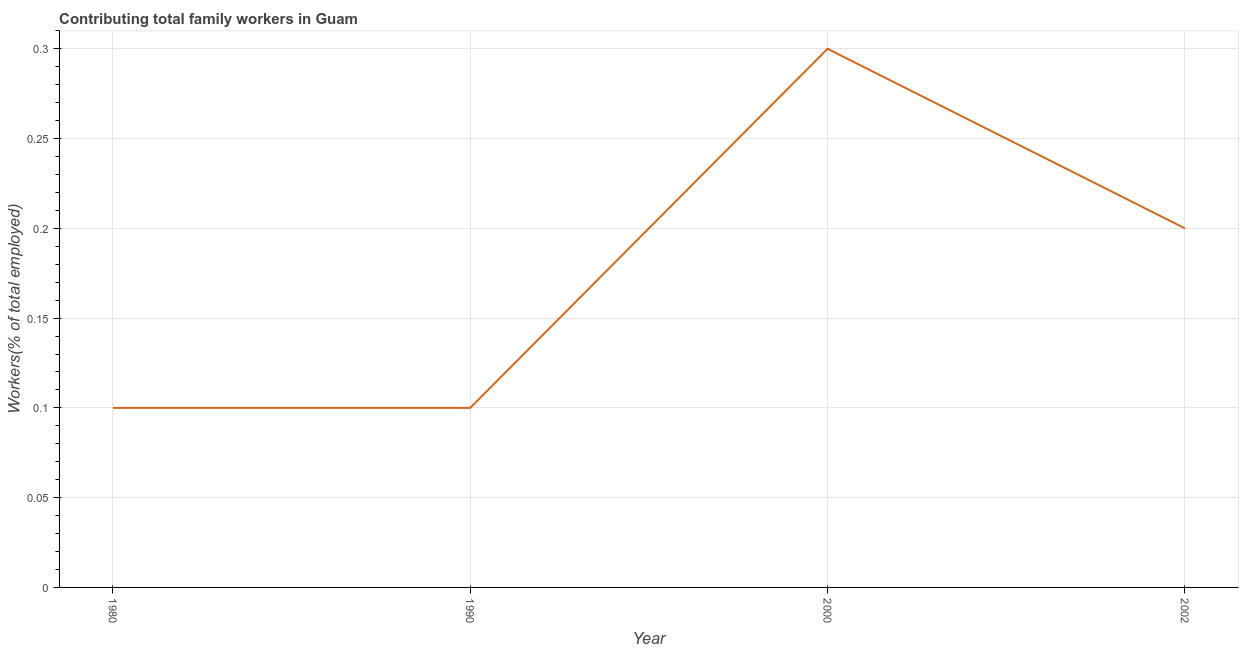What is the contributing family workers in 2000?
Your answer should be compact. 0.3. Across all years, what is the maximum contributing family workers?
Provide a succinct answer. 0.3. Across all years, what is the minimum contributing family workers?
Keep it short and to the point. 0.1. What is the sum of the contributing family workers?
Ensure brevity in your answer.  0.7. What is the difference between the contributing family workers in 1980 and 1990?
Ensure brevity in your answer.  0. What is the average contributing family workers per year?
Make the answer very short. 0.18. What is the median contributing family workers?
Give a very brief answer. 0.15. What is the ratio of the contributing family workers in 1990 to that in 2000?
Give a very brief answer. 0.33. Is the contributing family workers in 2000 less than that in 2002?
Your response must be concise. No. Is the difference between the contributing family workers in 1990 and 2002 greater than the difference between any two years?
Offer a terse response. No. What is the difference between the highest and the second highest contributing family workers?
Keep it short and to the point. 0.1. Is the sum of the contributing family workers in 1980 and 2000 greater than the maximum contributing family workers across all years?
Offer a terse response. Yes. What is the difference between the highest and the lowest contributing family workers?
Keep it short and to the point. 0.2. How many lines are there?
Ensure brevity in your answer.  1. What is the difference between two consecutive major ticks on the Y-axis?
Your response must be concise. 0.05. Are the values on the major ticks of Y-axis written in scientific E-notation?
Offer a terse response. No. Does the graph contain any zero values?
Offer a very short reply. No. What is the title of the graph?
Ensure brevity in your answer.  Contributing total family workers in Guam. What is the label or title of the Y-axis?
Offer a very short reply. Workers(% of total employed). What is the Workers(% of total employed) of 1980?
Give a very brief answer. 0.1. What is the Workers(% of total employed) in 1990?
Ensure brevity in your answer.  0.1. What is the Workers(% of total employed) in 2000?
Make the answer very short. 0.3. What is the Workers(% of total employed) in 2002?
Provide a succinct answer. 0.2. What is the difference between the Workers(% of total employed) in 1980 and 1990?
Ensure brevity in your answer.  0. What is the difference between the Workers(% of total employed) in 1980 and 2000?
Give a very brief answer. -0.2. What is the difference between the Workers(% of total employed) in 1980 and 2002?
Provide a succinct answer. -0.1. What is the difference between the Workers(% of total employed) in 2000 and 2002?
Provide a short and direct response. 0.1. What is the ratio of the Workers(% of total employed) in 1980 to that in 2000?
Provide a succinct answer. 0.33. What is the ratio of the Workers(% of total employed) in 1990 to that in 2000?
Make the answer very short. 0.33. What is the ratio of the Workers(% of total employed) in 1990 to that in 2002?
Give a very brief answer. 0.5. What is the ratio of the Workers(% of total employed) in 2000 to that in 2002?
Your answer should be compact. 1.5. 